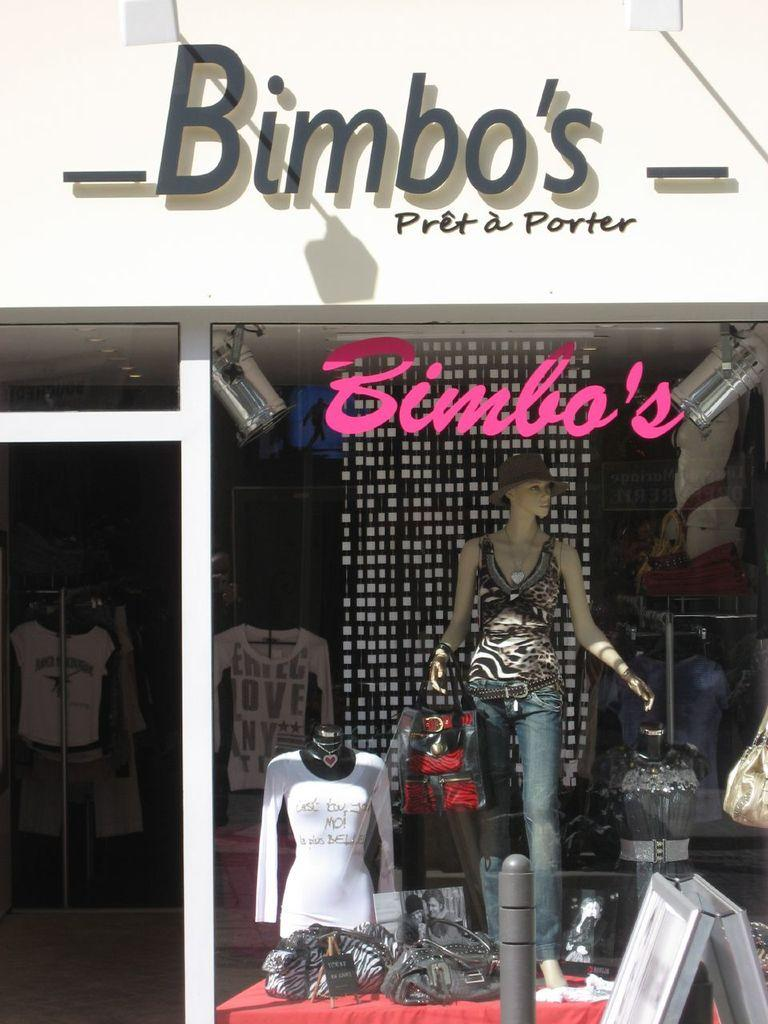<image>
Provide a brief description of the given image. A window display with the word Bimbo's over it. 